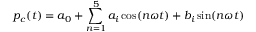Convert formula to latex. <formula><loc_0><loc_0><loc_500><loc_500>p _ { c } ( t ) = a _ { 0 } + \sum _ { n = 1 } ^ { 5 } a _ { i } \cos ( n \omega t ) + b _ { i } \sin ( n \omega t )</formula> 